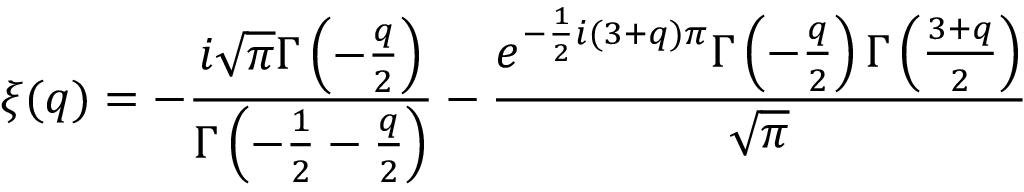<formula> <loc_0><loc_0><loc_500><loc_500>\xi ( q ) = - \frac { i \sqrt { \pi } \Gamma \left ( - \frac { q } { 2 } \right ) } { \Gamma \left ( - \frac { 1 } { 2 } - \frac { q } { 2 } \right ) } - \frac { e ^ { - \frac { 1 } { 2 } i ( 3 + q ) \pi } \Gamma \left ( - \frac { q } { 2 } \right ) \Gamma \left ( \frac { 3 + q } { 2 } \right ) } { \sqrt { \pi } }</formula> 